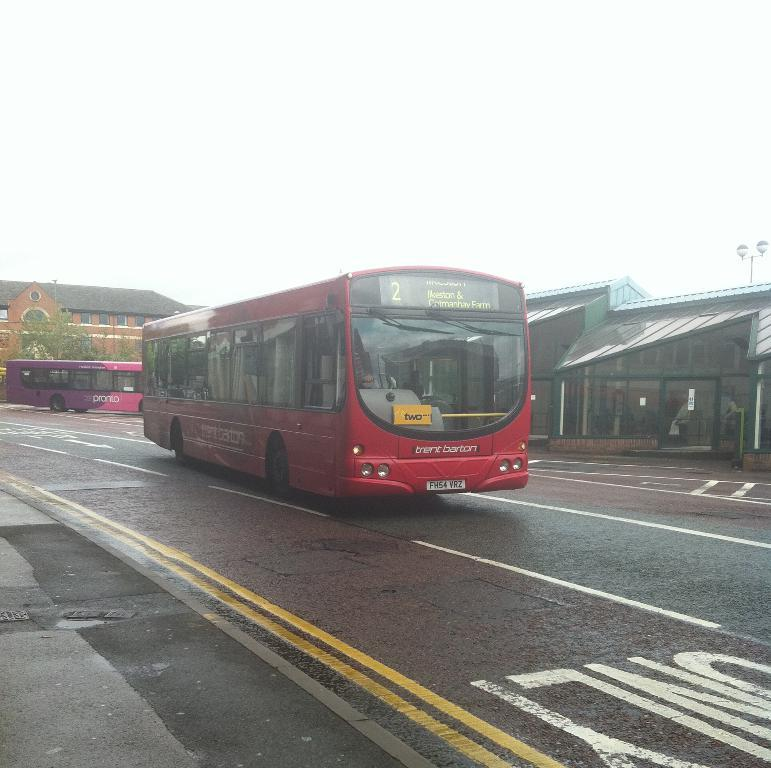How many buses can be seen on the road in the image? There are two buses on the road in the image. What are the buses doing in the image? The buses are moving in the image. Where are the buses located in relation to the bus bay? The buses are beside a bus bay in the image. What can be seen in the background of the image? There is a building in the background of the image. How would you describe the weather based on the image? The climate is breezy in the image. What type of whistle can be heard coming from the buses in the image? There is no whistle present in the image, and therefore no sound can be heard. 